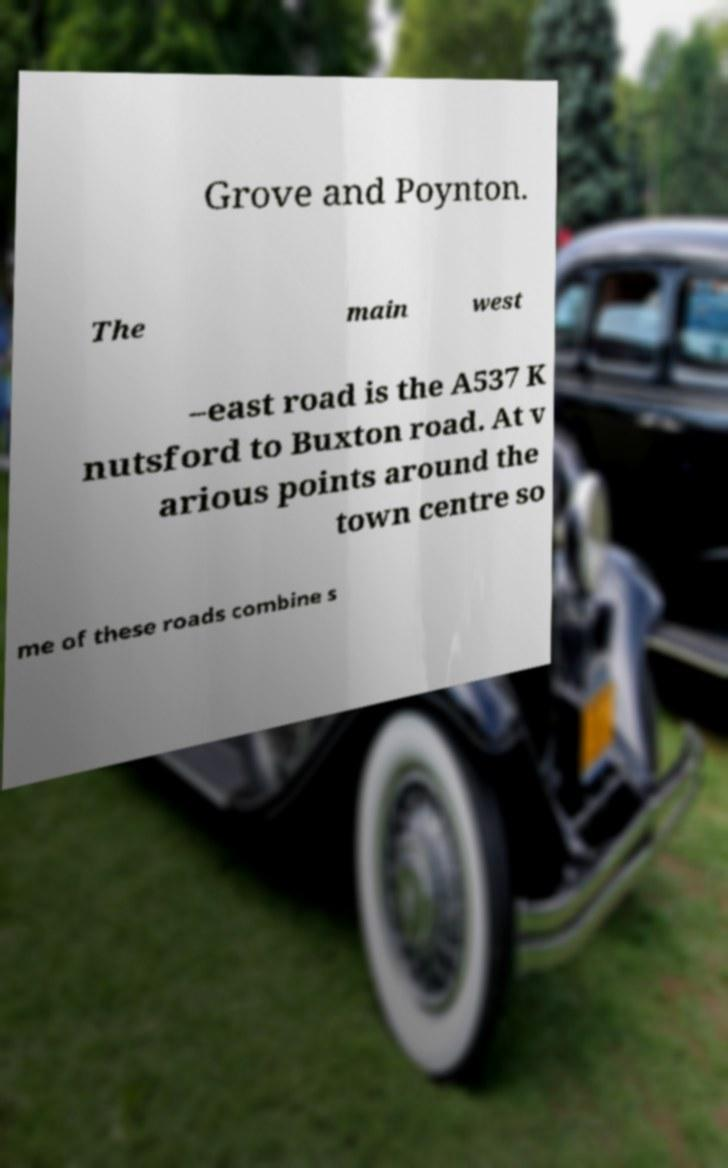Please identify and transcribe the text found in this image. Grove and Poynton. The main west –east road is the A537 K nutsford to Buxton road. At v arious points around the town centre so me of these roads combine s 